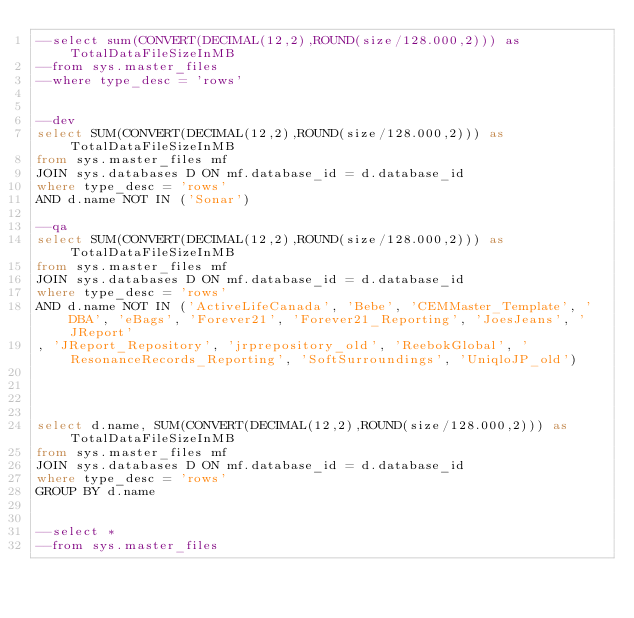<code> <loc_0><loc_0><loc_500><loc_500><_SQL_>--select sum(CONVERT(DECIMAL(12,2),ROUND(size/128.000,2))) as TotalDataFileSizeInMB
--from sys.master_files
--where type_desc = 'rows'


--dev
select SUM(CONVERT(DECIMAL(12,2),ROUND(size/128.000,2))) as TotalDataFileSizeInMB
from sys.master_files mf
JOIN sys.databases D ON mf.database_id = d.database_id
where type_desc = 'rows'
AND d.name NOT IN ('Sonar')

--qa
select SUM(CONVERT(DECIMAL(12,2),ROUND(size/128.000,2))) as TotalDataFileSizeInMB
from sys.master_files mf
JOIN sys.databases D ON mf.database_id = d.database_id
where type_desc = 'rows'
AND d.name NOT IN ('ActiveLifeCanada', 'Bebe', 'CEMMaster_Template', 'DBA', 'eBags', 'Forever21', 'Forever21_Reporting', 'JoesJeans', 'JReport'
, 'JReport_Repository', 'jrprepository_old', 'ReebokGlobal', 'ResonanceRecords_Reporting', 'SoftSurroundings', 'UniqloJP_old')




select d.name, SUM(CONVERT(DECIMAL(12,2),ROUND(size/128.000,2))) as TotalDataFileSizeInMB
from sys.master_files mf
JOIN sys.databases D ON mf.database_id = d.database_id
where type_desc = 'rows'
GROUP BY d.name


--select *
--from sys.master_files
</code> 